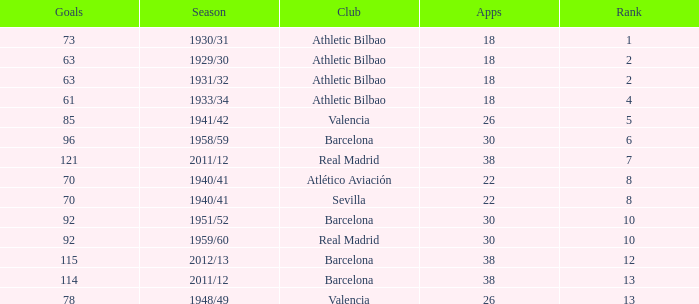How many apps when the rank was after 13 and having more than 73 goals? None. 